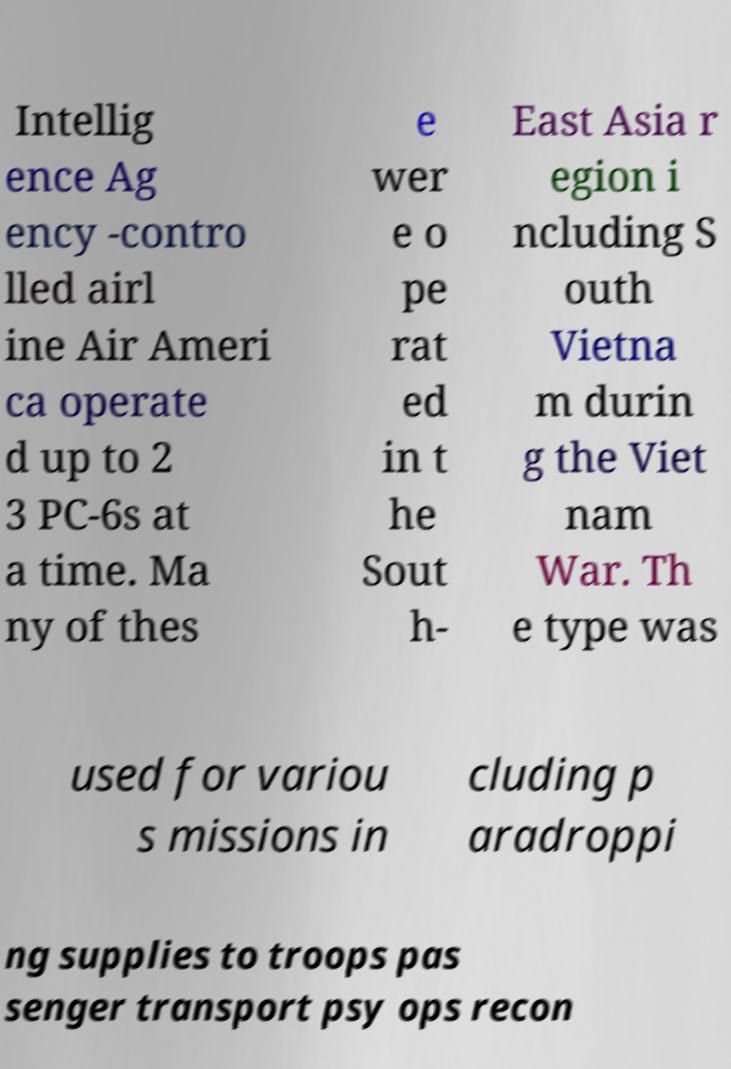Could you extract and type out the text from this image? Intellig ence Ag ency -contro lled airl ine Air Ameri ca operate d up to 2 3 PC-6s at a time. Ma ny of thes e wer e o pe rat ed in t he Sout h- East Asia r egion i ncluding S outh Vietna m durin g the Viet nam War. Th e type was used for variou s missions in cluding p aradroppi ng supplies to troops pas senger transport psy ops recon 